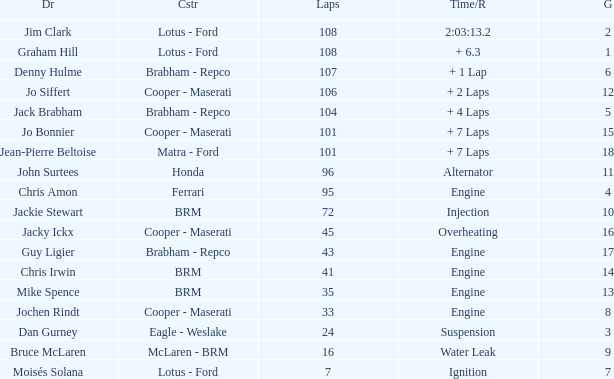What was the constructor when there were 95 laps and a grid less than 15? Ferrari. 